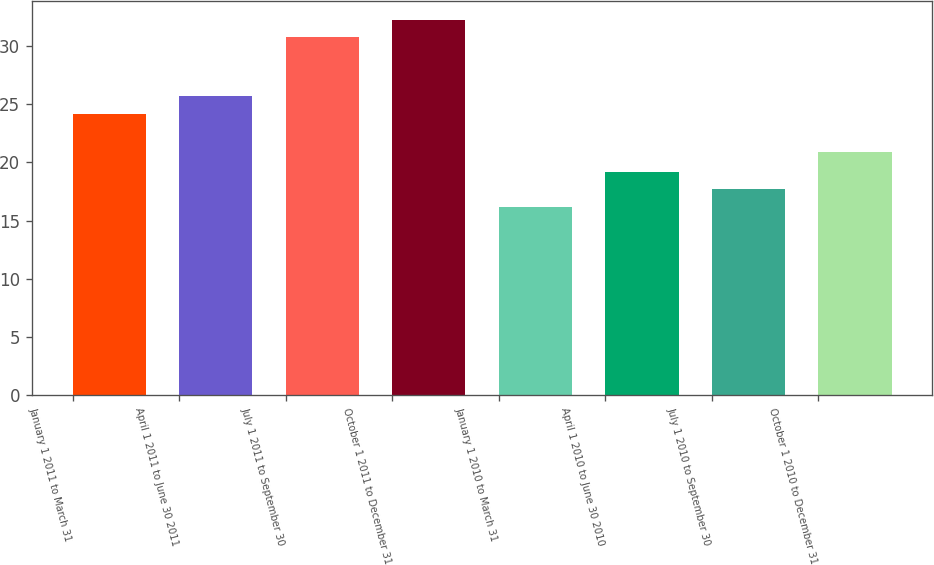<chart> <loc_0><loc_0><loc_500><loc_500><bar_chart><fcel>January 1 2011 to March 31<fcel>April 1 2011 to June 30 2011<fcel>July 1 2011 to September 30<fcel>October 1 2011 to December 31<fcel>January 1 2010 to March 31<fcel>April 1 2010 to June 30 2010<fcel>July 1 2010 to September 30<fcel>October 1 2010 to December 31<nl><fcel>24.19<fcel>25.69<fcel>30.75<fcel>32.25<fcel>16.2<fcel>19.2<fcel>17.7<fcel>20.93<nl></chart> 